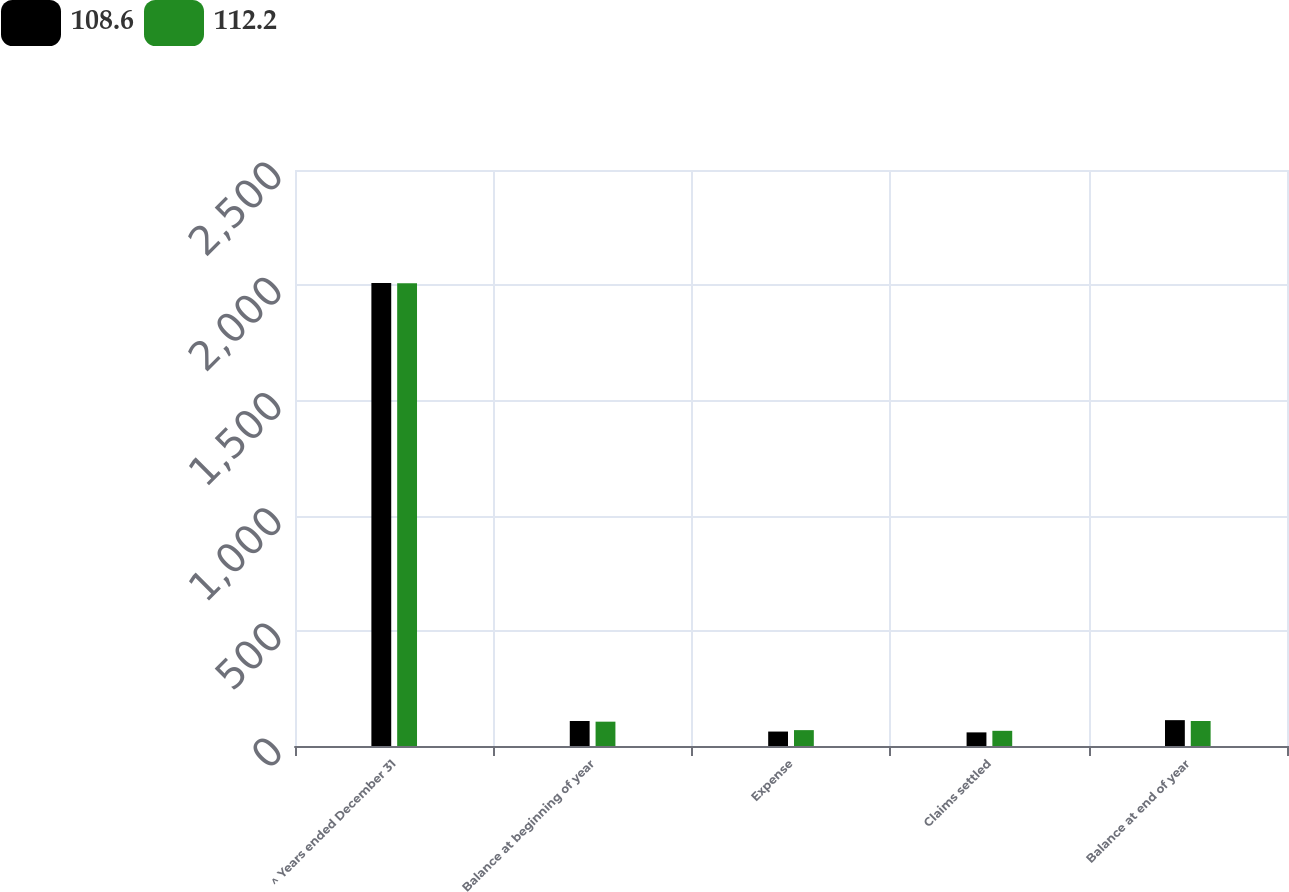Convert chart to OTSL. <chart><loc_0><loc_0><loc_500><loc_500><stacked_bar_chart><ecel><fcel>^ Years ended December 31<fcel>Balance at beginning of year<fcel>Expense<fcel>Claims settled<fcel>Balance at end of year<nl><fcel>108.6<fcel>2010<fcel>108.6<fcel>62.7<fcel>59.1<fcel>112.2<nl><fcel>112.2<fcel>2009<fcel>105.6<fcel>68.9<fcel>65.9<fcel>108.6<nl></chart> 